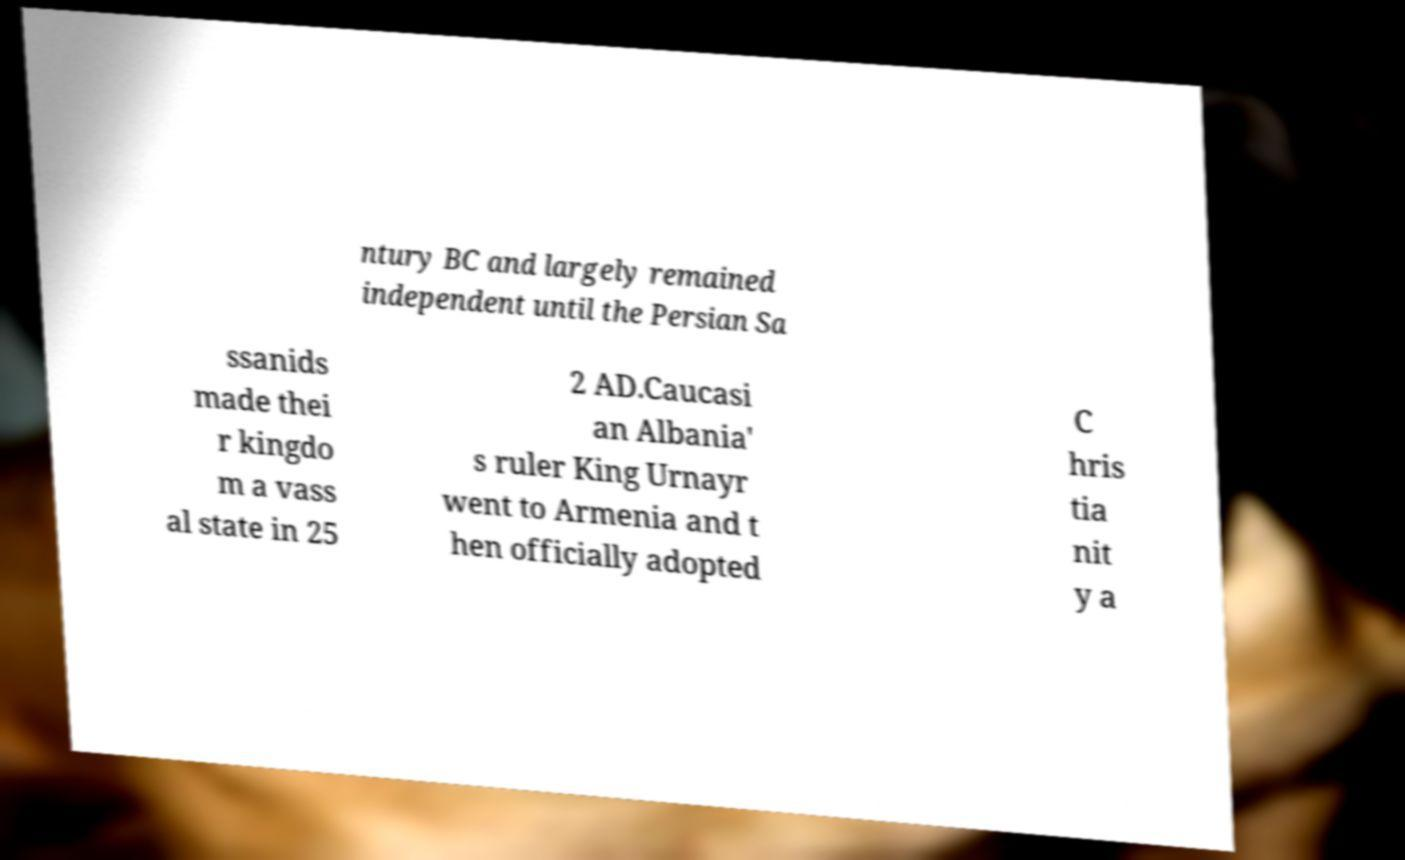I need the written content from this picture converted into text. Can you do that? ntury BC and largely remained independent until the Persian Sa ssanids made thei r kingdo m a vass al state in 25 2 AD.Caucasi an Albania' s ruler King Urnayr went to Armenia and t hen officially adopted C hris tia nit y a 